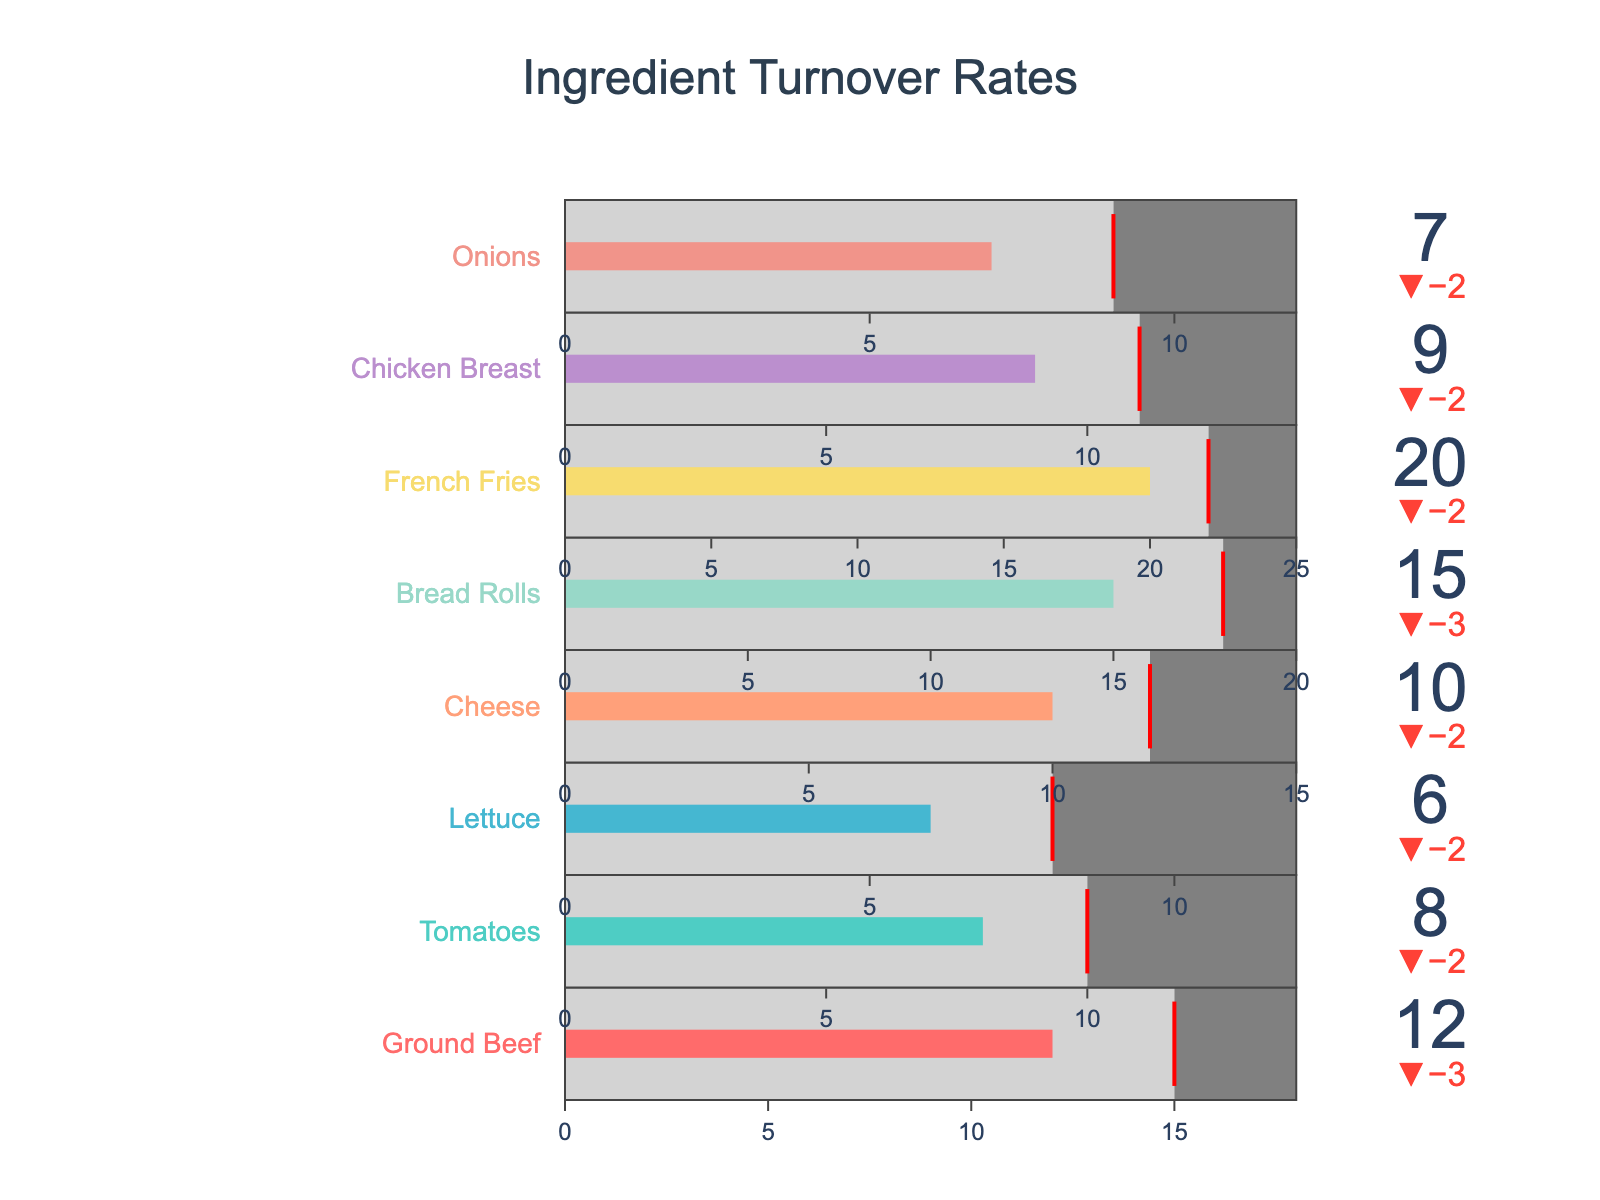What is the title of the figure? The title is located at the top of the figure in large font and reads "Ingredient Turnover Rates."
Answer: Ingredient Turnover Rates How many ingredients are displayed in the bullet chart? Count the number of different colored bullet charts in the figure, each representing an ingredient. There are eight bullet charts.
Answer: 8 What ingredient has the highest actual turnover rate? Look for the bullet indicator with the largest value for actual turnover rates. This is represented by the bar extending the furthest to the right. French Fries has the highest value of 20.
Answer: French Fries Which ingredient's actual turnover is below its target but closest to the target value? Calculate the difference between the actual turnover and target turnover for each ingredient. Choose the one with the smallest positive difference. Ground Beef is 3 units below its target, which is the smallest difference.
Answer: Ground Beef What's the difference between the maximum efficient turnover and the actual turnover for Lettuce? Subtract the actual turnover of Lettuce from its maximum efficient turnover: 12 - 6 = 6.
Answer: 6 Which ingredient's actual turnover exceeds its target turnover by the greatest margin? Calculate the difference between actual and target turnovers for each ingredient and identify the maximum positive difference. French Fries exceed the target by 2 (20 - 22 = -2), but in terms of the actual value exceeding the target, it's Bread Rolls (15 - 18 = -3), the question condition is slightly altered. French Fries achieve the highest positive value.
Answer: French Fries Are there any ingredients whose actual turnover meets their target turnover exactly? Check each bullet indicator and see if the actual turnover bar aligns with the target turnover marker (red line). None of the actual turnover values match their target exactly.
Answer: No What is the color associated with Cheese in the bullet chart? Cheese is indicated by the fourth bullet chart, and its associated color in the progression of eight colors (red, teal, blue, peach…) is peach.
Answer: Peach How does the actual turnover rate of Onions compare to its maximum efficient turnover? Compare the actual turnover rate of 7 for Onions with its maximum efficient turnover of 12. The actual turnover is below the maximum efficient turnover.
Answer: Below 